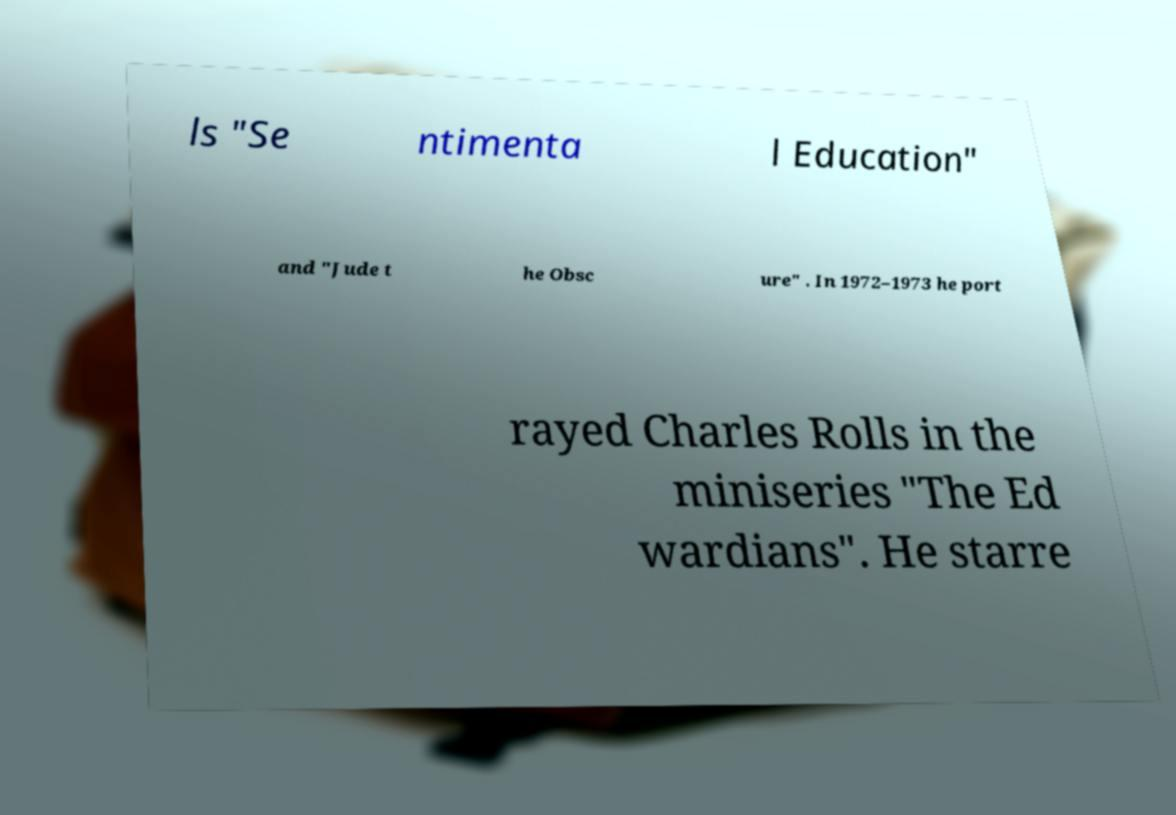Could you assist in decoding the text presented in this image and type it out clearly? ls "Se ntimenta l Education" and "Jude t he Obsc ure" . In 1972–1973 he port rayed Charles Rolls in the miniseries "The Ed wardians". He starre 